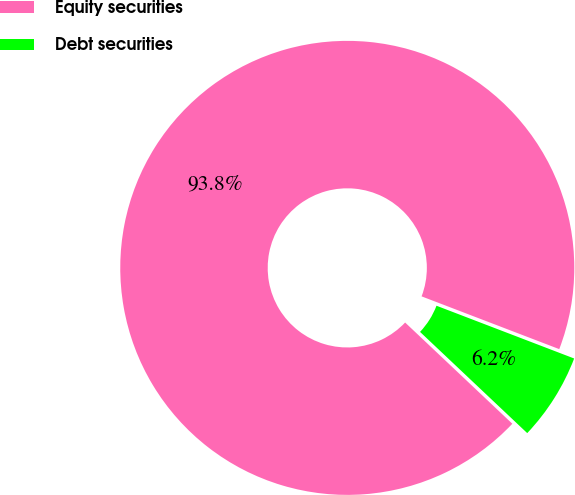<chart> <loc_0><loc_0><loc_500><loc_500><pie_chart><fcel>Equity securities<fcel>Debt securities<nl><fcel>93.78%<fcel>6.22%<nl></chart> 